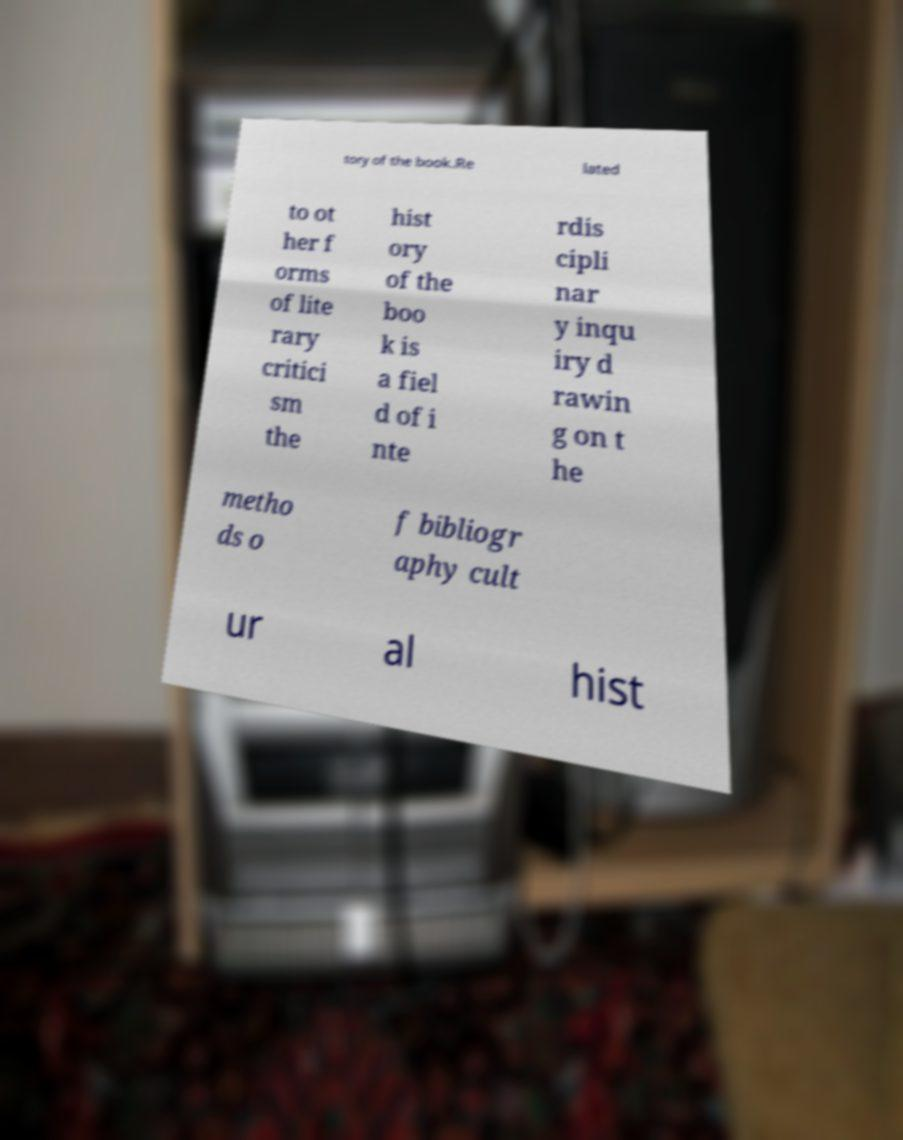Can you accurately transcribe the text from the provided image for me? tory of the book.Re lated to ot her f orms of lite rary critici sm the hist ory of the boo k is a fiel d of i nte rdis cipli nar y inqu iry d rawin g on t he metho ds o f bibliogr aphy cult ur al hist 